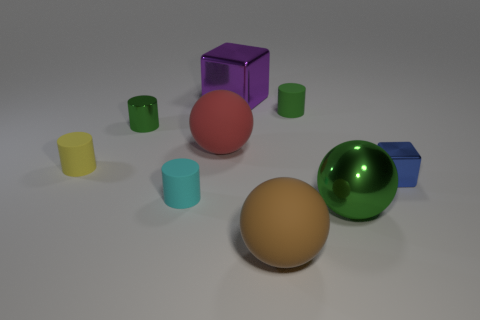Can you tell me about the lighting in this scene? The lighting in the scene appears to be diffuse overhead lighting, likely from multiple sources. This is evident from the soft shadows under the objects and the lack of harsh, directional highlights. 